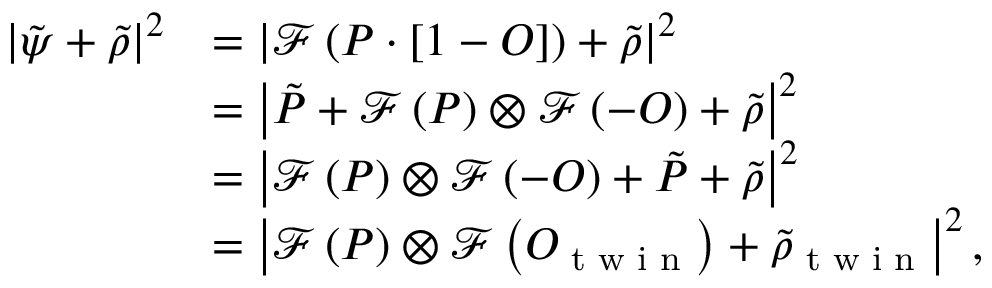<formula> <loc_0><loc_0><loc_500><loc_500>\begin{array} { r l } { \left | \tilde { \psi } + \tilde { \rho } \right | ^ { 2 } } & { = \left | \mathcal { F } \left ( P \cdot \left [ 1 - O \right ] \right ) + \tilde { \rho } \right | ^ { 2 } } \\ & { = \left | \tilde { P } + \mathcal { F } \left ( P \right ) \otimes \mathcal { F } \left ( - O \right ) + \tilde { \rho } \right | ^ { 2 } } \\ & { = \left | \mathcal { F } \left ( P \right ) \otimes \mathcal { F } \left ( - O \right ) + \tilde { P } + \tilde { \rho } \right | ^ { 2 } } \\ & { = \left | \mathcal { F } \left ( P \right ) \otimes \mathcal { F } \left ( O _ { t w i n } \right ) + \tilde { \rho } _ { t w i n } \right | ^ { 2 } , } \end{array}</formula> 